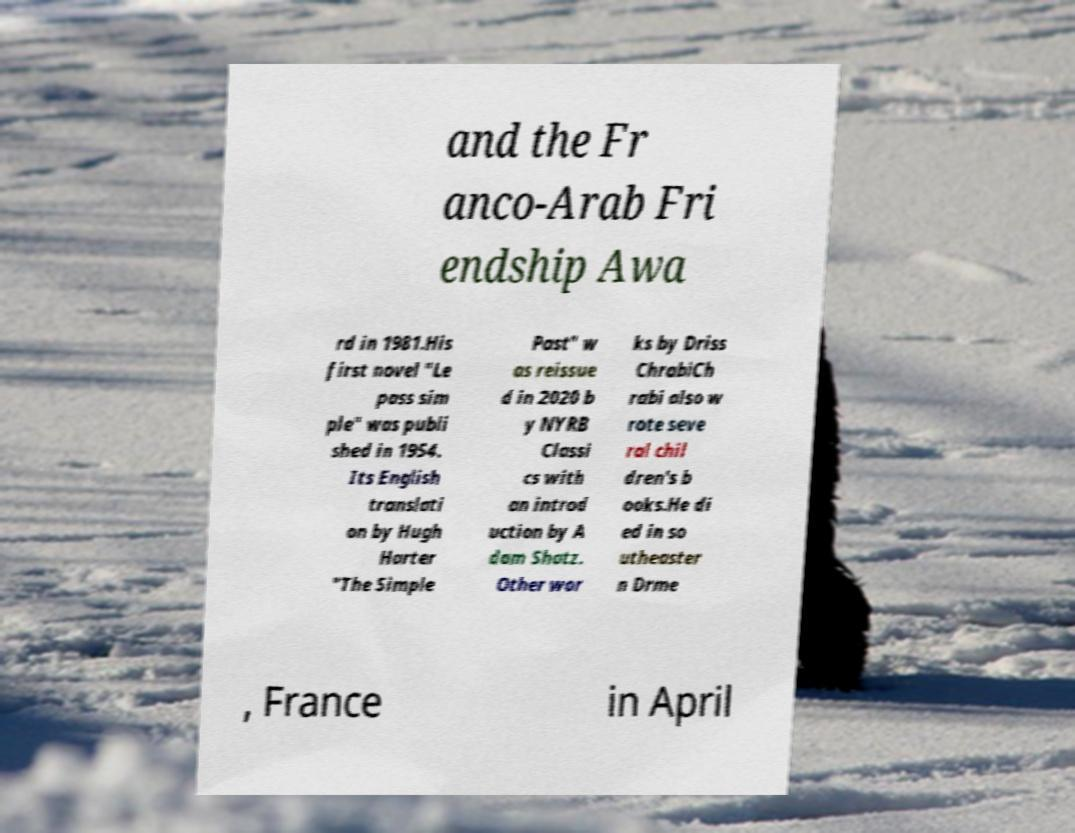For documentation purposes, I need the text within this image transcribed. Could you provide that? and the Fr anco-Arab Fri endship Awa rd in 1981.His first novel "Le pass sim ple" was publi shed in 1954. Its English translati on by Hugh Harter "The Simple Past" w as reissue d in 2020 b y NYRB Classi cs with an introd uction by A dam Shatz. Other wor ks by Driss ChrabiCh rabi also w rote seve ral chil dren's b ooks.He di ed in so utheaster n Drme , France in April 